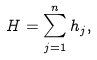Convert formula to latex. <formula><loc_0><loc_0><loc_500><loc_500>H = \sum _ { j = 1 } ^ { n } h _ { j } ,</formula> 